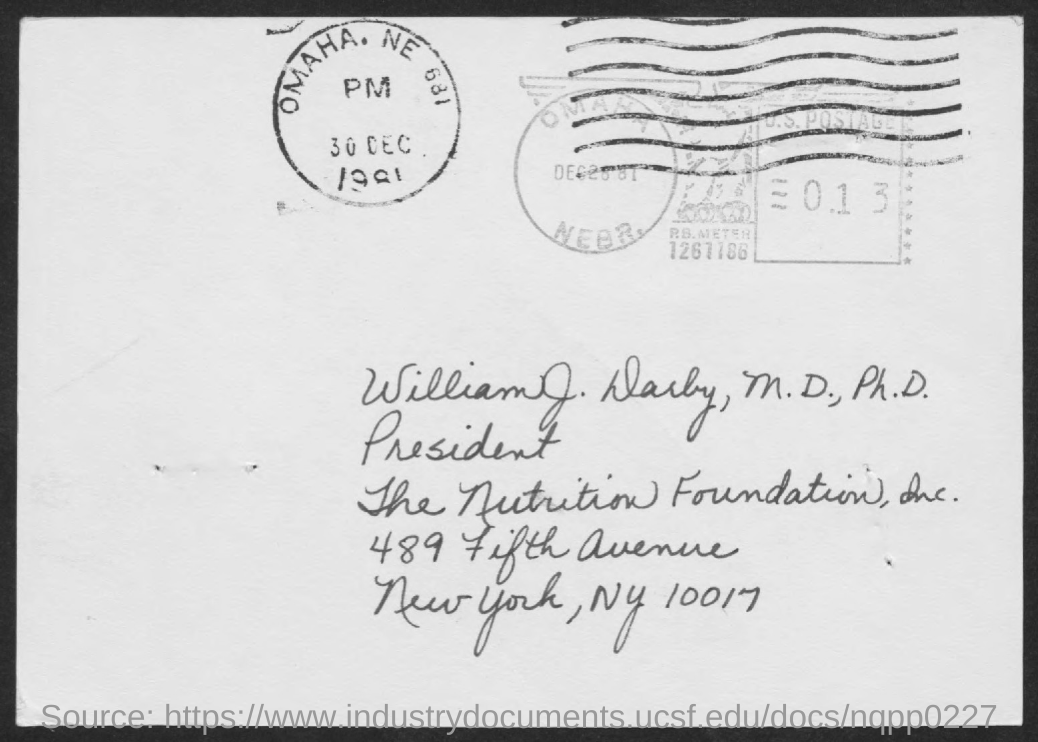Draw attention to some important aspects in this diagram. The nutrition foundation is located in New York City. The letter bears the name William J. Darby, M.D., Ph.D. Dr. William J. Darby is designated as the president. 